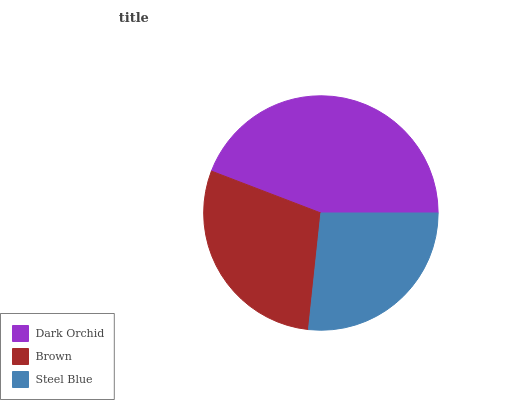Is Steel Blue the minimum?
Answer yes or no. Yes. Is Dark Orchid the maximum?
Answer yes or no. Yes. Is Brown the minimum?
Answer yes or no. No. Is Brown the maximum?
Answer yes or no. No. Is Dark Orchid greater than Brown?
Answer yes or no. Yes. Is Brown less than Dark Orchid?
Answer yes or no. Yes. Is Brown greater than Dark Orchid?
Answer yes or no. No. Is Dark Orchid less than Brown?
Answer yes or no. No. Is Brown the high median?
Answer yes or no. Yes. Is Brown the low median?
Answer yes or no. Yes. Is Steel Blue the high median?
Answer yes or no. No. Is Steel Blue the low median?
Answer yes or no. No. 